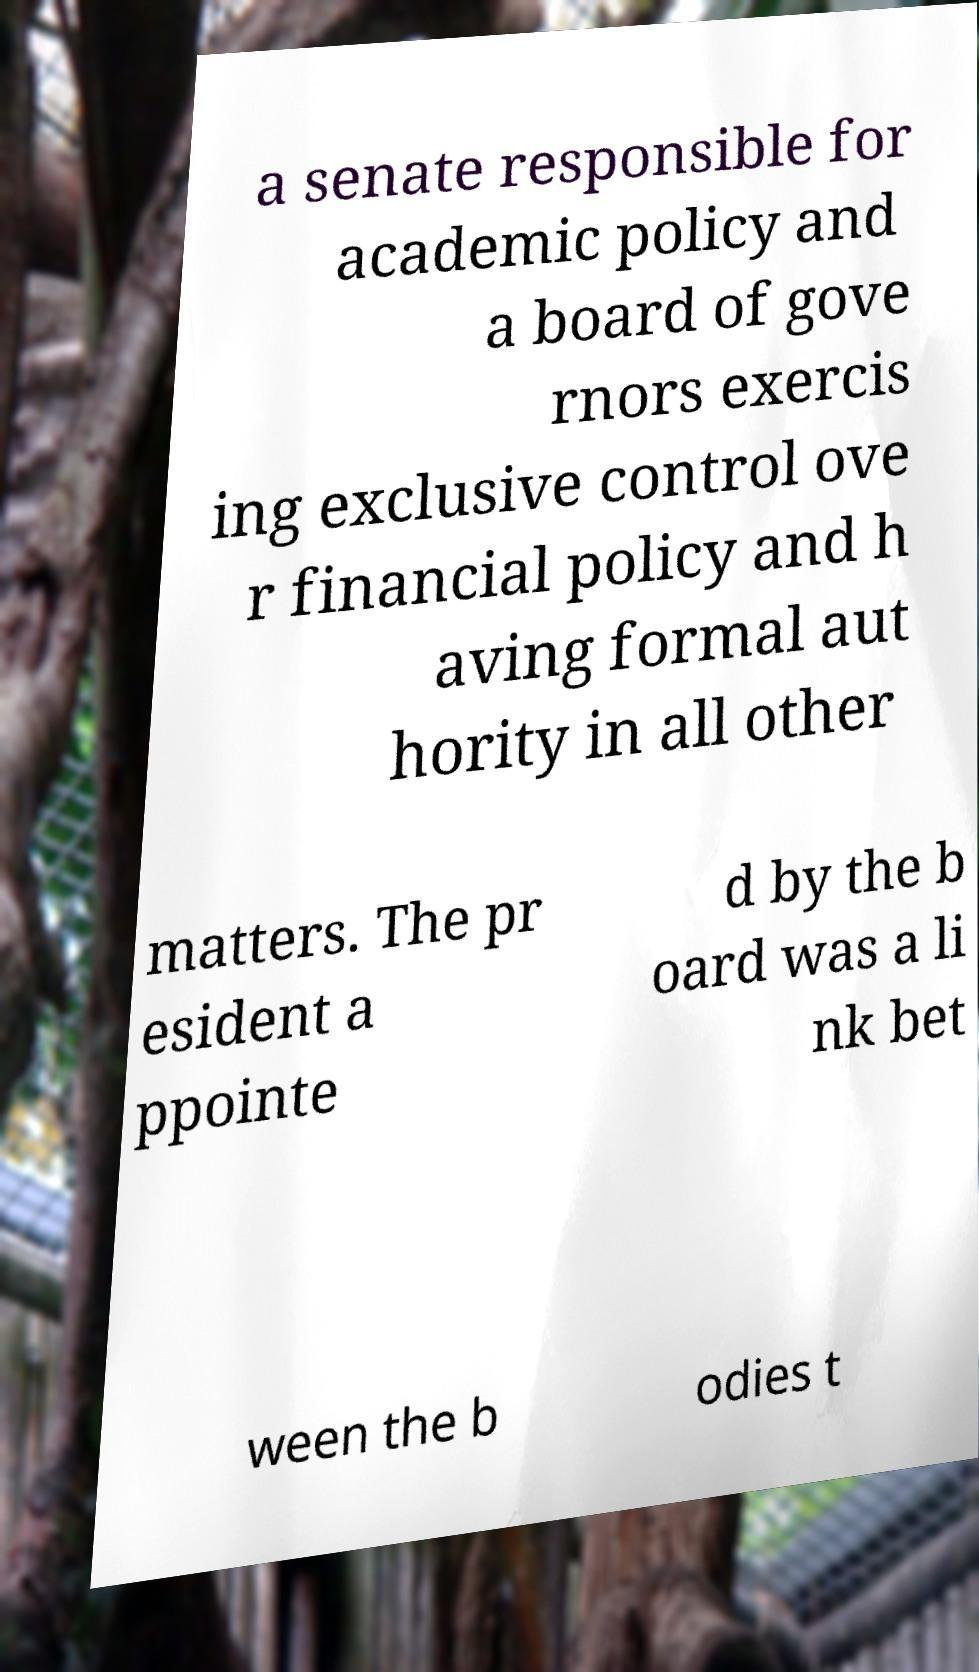Please read and relay the text visible in this image. What does it say? a senate responsible for academic policy and a board of gove rnors exercis ing exclusive control ove r financial policy and h aving formal aut hority in all other matters. The pr esident a ppointe d by the b oard was a li nk bet ween the b odies t 